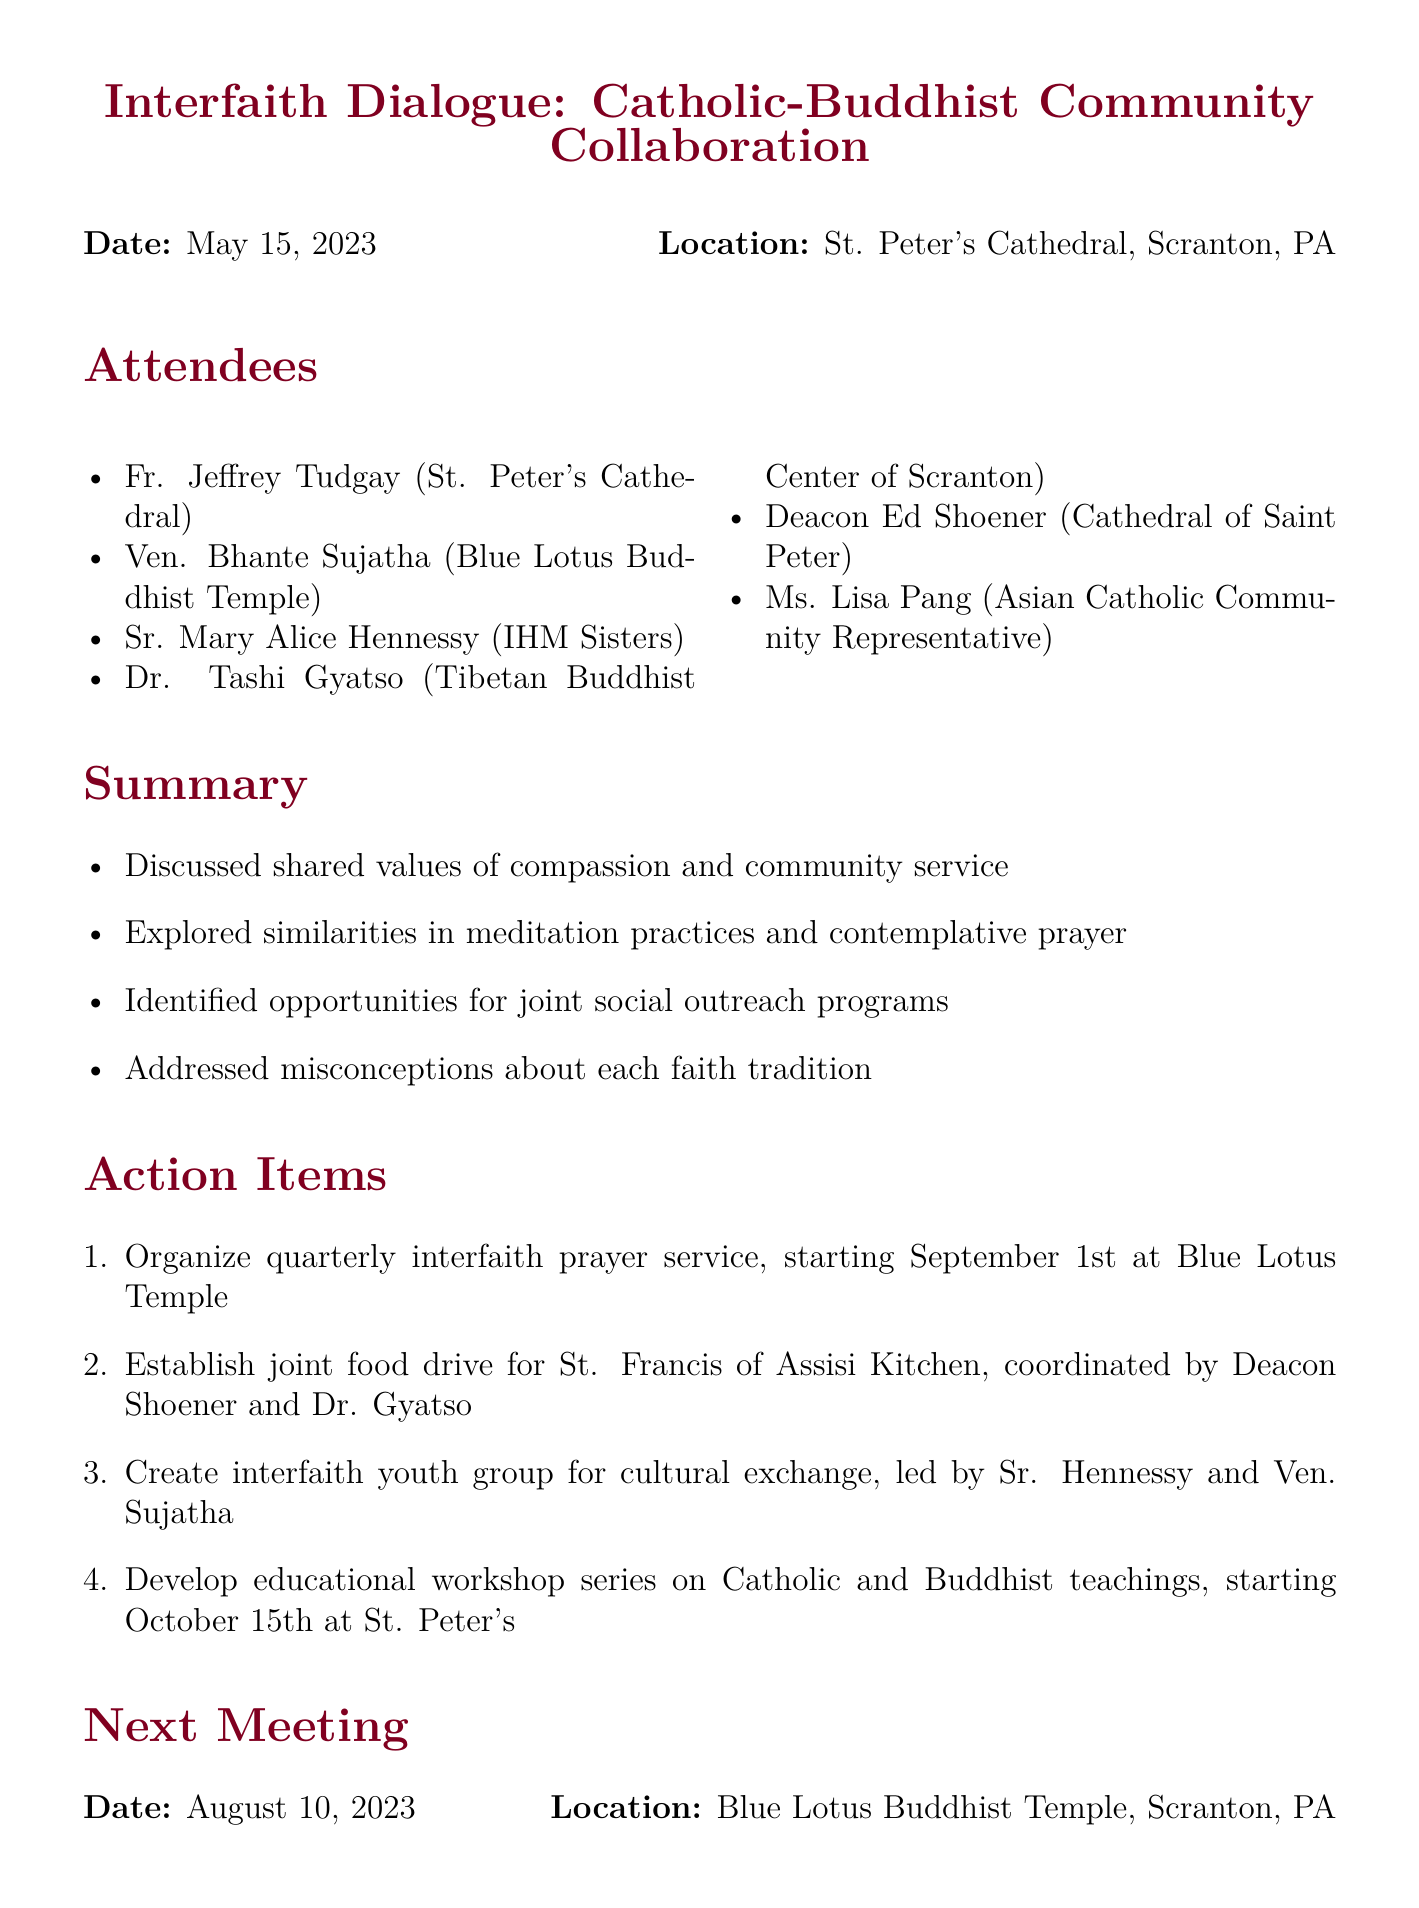what was the date of the meeting? The meeting was held on May 15, 2023, as stated in the document header.
Answer: May 15, 2023 where was the meeting held? The location of the meeting is specified in the document.
Answer: St. Peter's Cathedral, Scranton, PA who is one of the attendees from the Buddhist community? The document lists attendees and identifies members from the Buddhist community.
Answer: Ven. Bhante Sujatha what is one of the shared values discussed? The summary section mentions values discussed during the meeting.
Answer: compassion when is the next meeting scheduled? The date for the next meeting is provided at the end of the document.
Answer: August 10, 2023 how many action items were identified? The action items section lists the number of items discussed.
Answer: four who will coordinate the joint food drive? The document specifies the individuals responsible for the food drive.
Answer: Deacon Shoener and Dr. Gyatso what is the purpose of the interfaith youth group? The document indicates the goal of creating a youth group in the action items section.
Answer: cultural exchange what kind of event is proposed to start on September 1st? The action items section includes details about types of events scheduled.
Answer: interfaith prayer service 